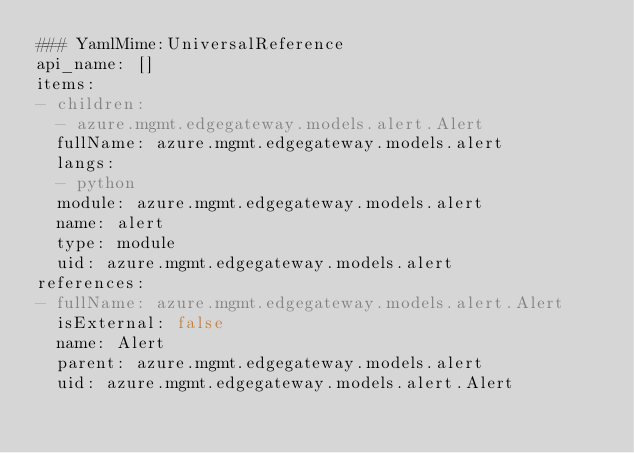Convert code to text. <code><loc_0><loc_0><loc_500><loc_500><_YAML_>### YamlMime:UniversalReference
api_name: []
items:
- children:
  - azure.mgmt.edgegateway.models.alert.Alert
  fullName: azure.mgmt.edgegateway.models.alert
  langs:
  - python
  module: azure.mgmt.edgegateway.models.alert
  name: alert
  type: module
  uid: azure.mgmt.edgegateway.models.alert
references:
- fullName: azure.mgmt.edgegateway.models.alert.Alert
  isExternal: false
  name: Alert
  parent: azure.mgmt.edgegateway.models.alert
  uid: azure.mgmt.edgegateway.models.alert.Alert
</code> 